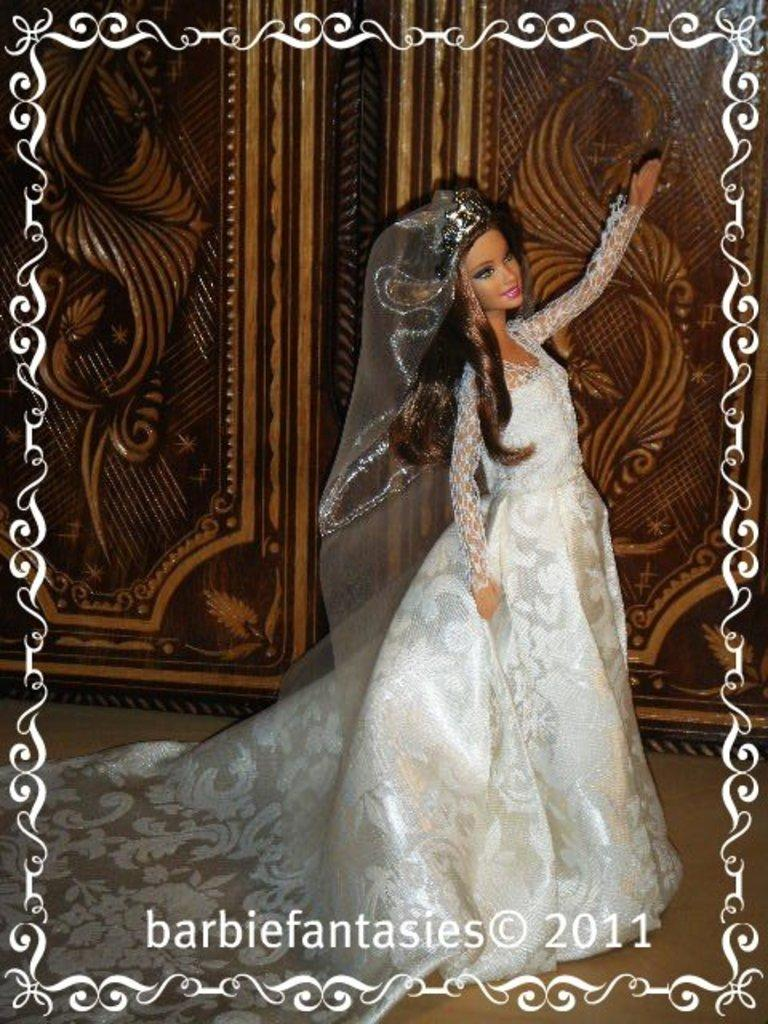What type of editing has been done to the image? The image is edited, but the specific type of editing is not mentioned in the facts. What can be seen in the image besides the editing? There is a doll in the image. What is located in the background of the image? There is a wooden object in the background of the image. Is there any text or logo visible in the image? Yes, there is a watermark at the bottom of the image. What type of lunchroom can be seen in the image? There is no lunchroom present in the image. What activity is the doll engaged in within the image? The facts do not mention any specific activity the doll is engaged in. 